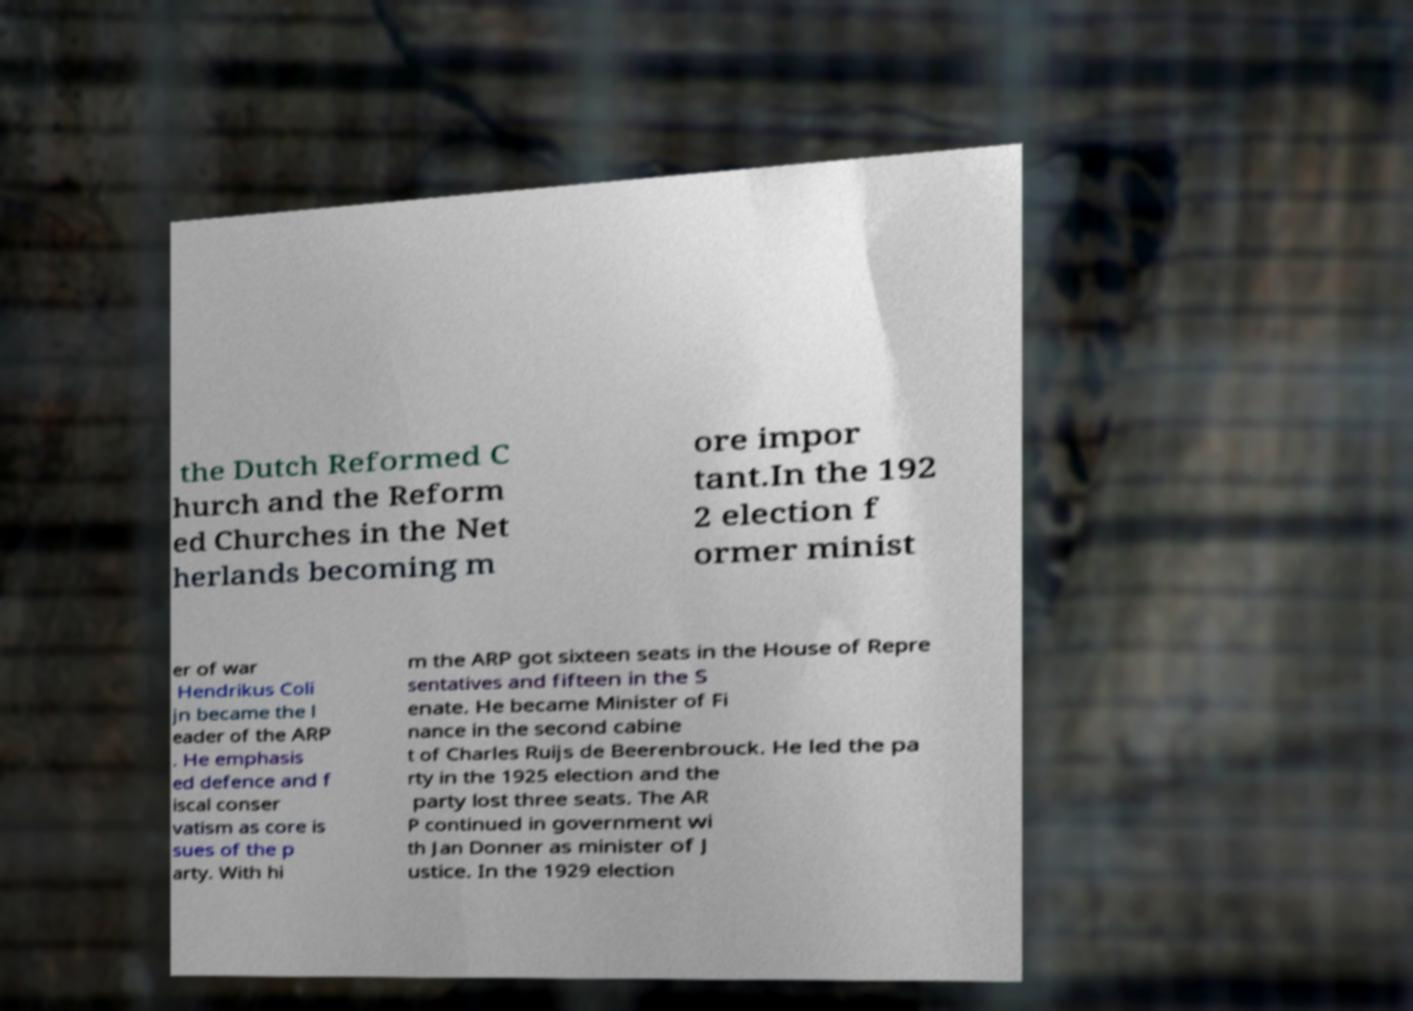Could you extract and type out the text from this image? the Dutch Reformed C hurch and the Reform ed Churches in the Net herlands becoming m ore impor tant.In the 192 2 election f ormer minist er of war Hendrikus Coli jn became the l eader of the ARP . He emphasis ed defence and f iscal conser vatism as core is sues of the p arty. With hi m the ARP got sixteen seats in the House of Repre sentatives and fifteen in the S enate. He became Minister of Fi nance in the second cabine t of Charles Ruijs de Beerenbrouck. He led the pa rty in the 1925 election and the party lost three seats. The AR P continued in government wi th Jan Donner as minister of J ustice. In the 1929 election 